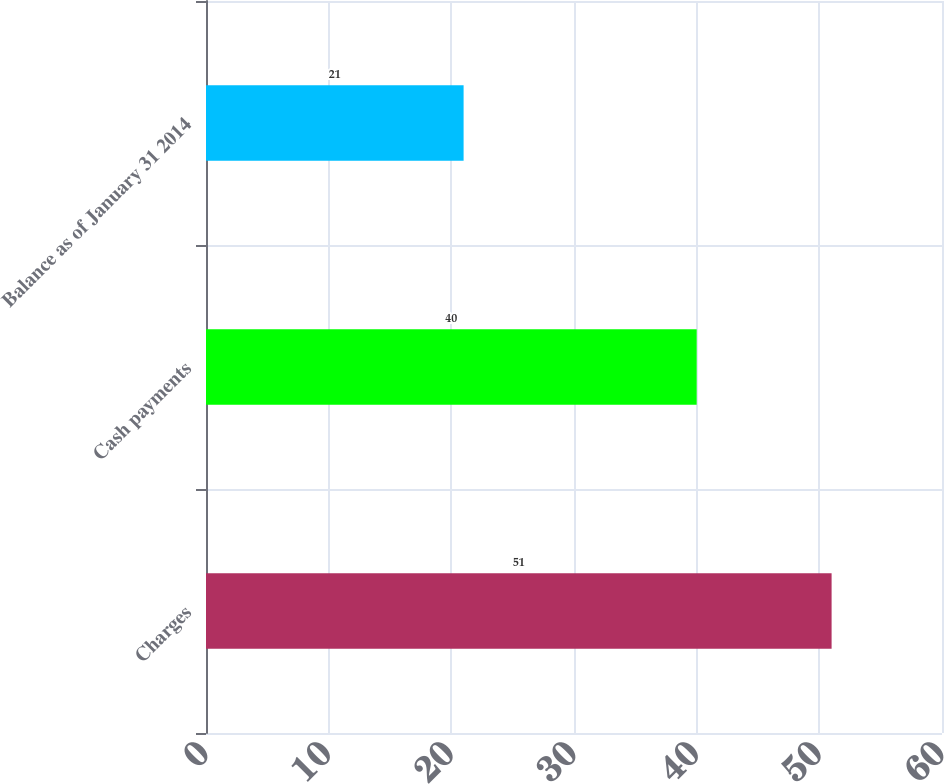<chart> <loc_0><loc_0><loc_500><loc_500><bar_chart><fcel>Charges<fcel>Cash payments<fcel>Balance as of January 31 2014<nl><fcel>51<fcel>40<fcel>21<nl></chart> 